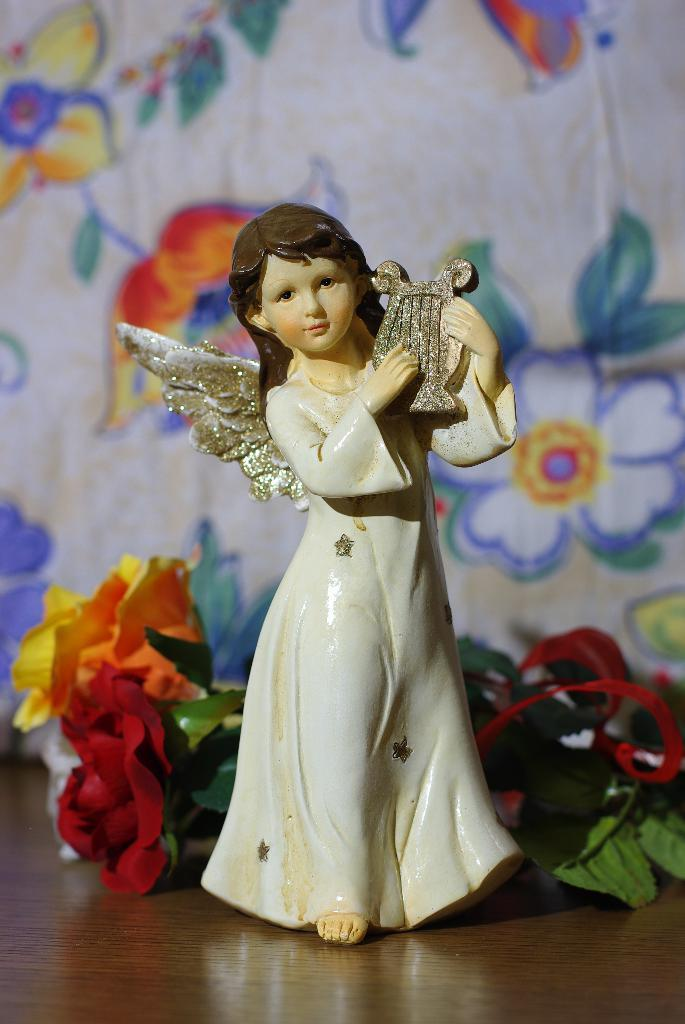What is the main subject in the image? There is a statue in the image. What other objects can be seen in the image besides the statue? There are decorative flowers on a table in the image. What can be seen in the background of the image? There is a wall with a design in the background of the image. How does the statue react to the surprise in the image? There is no surprise present in the image, so the statue does not react to it. 